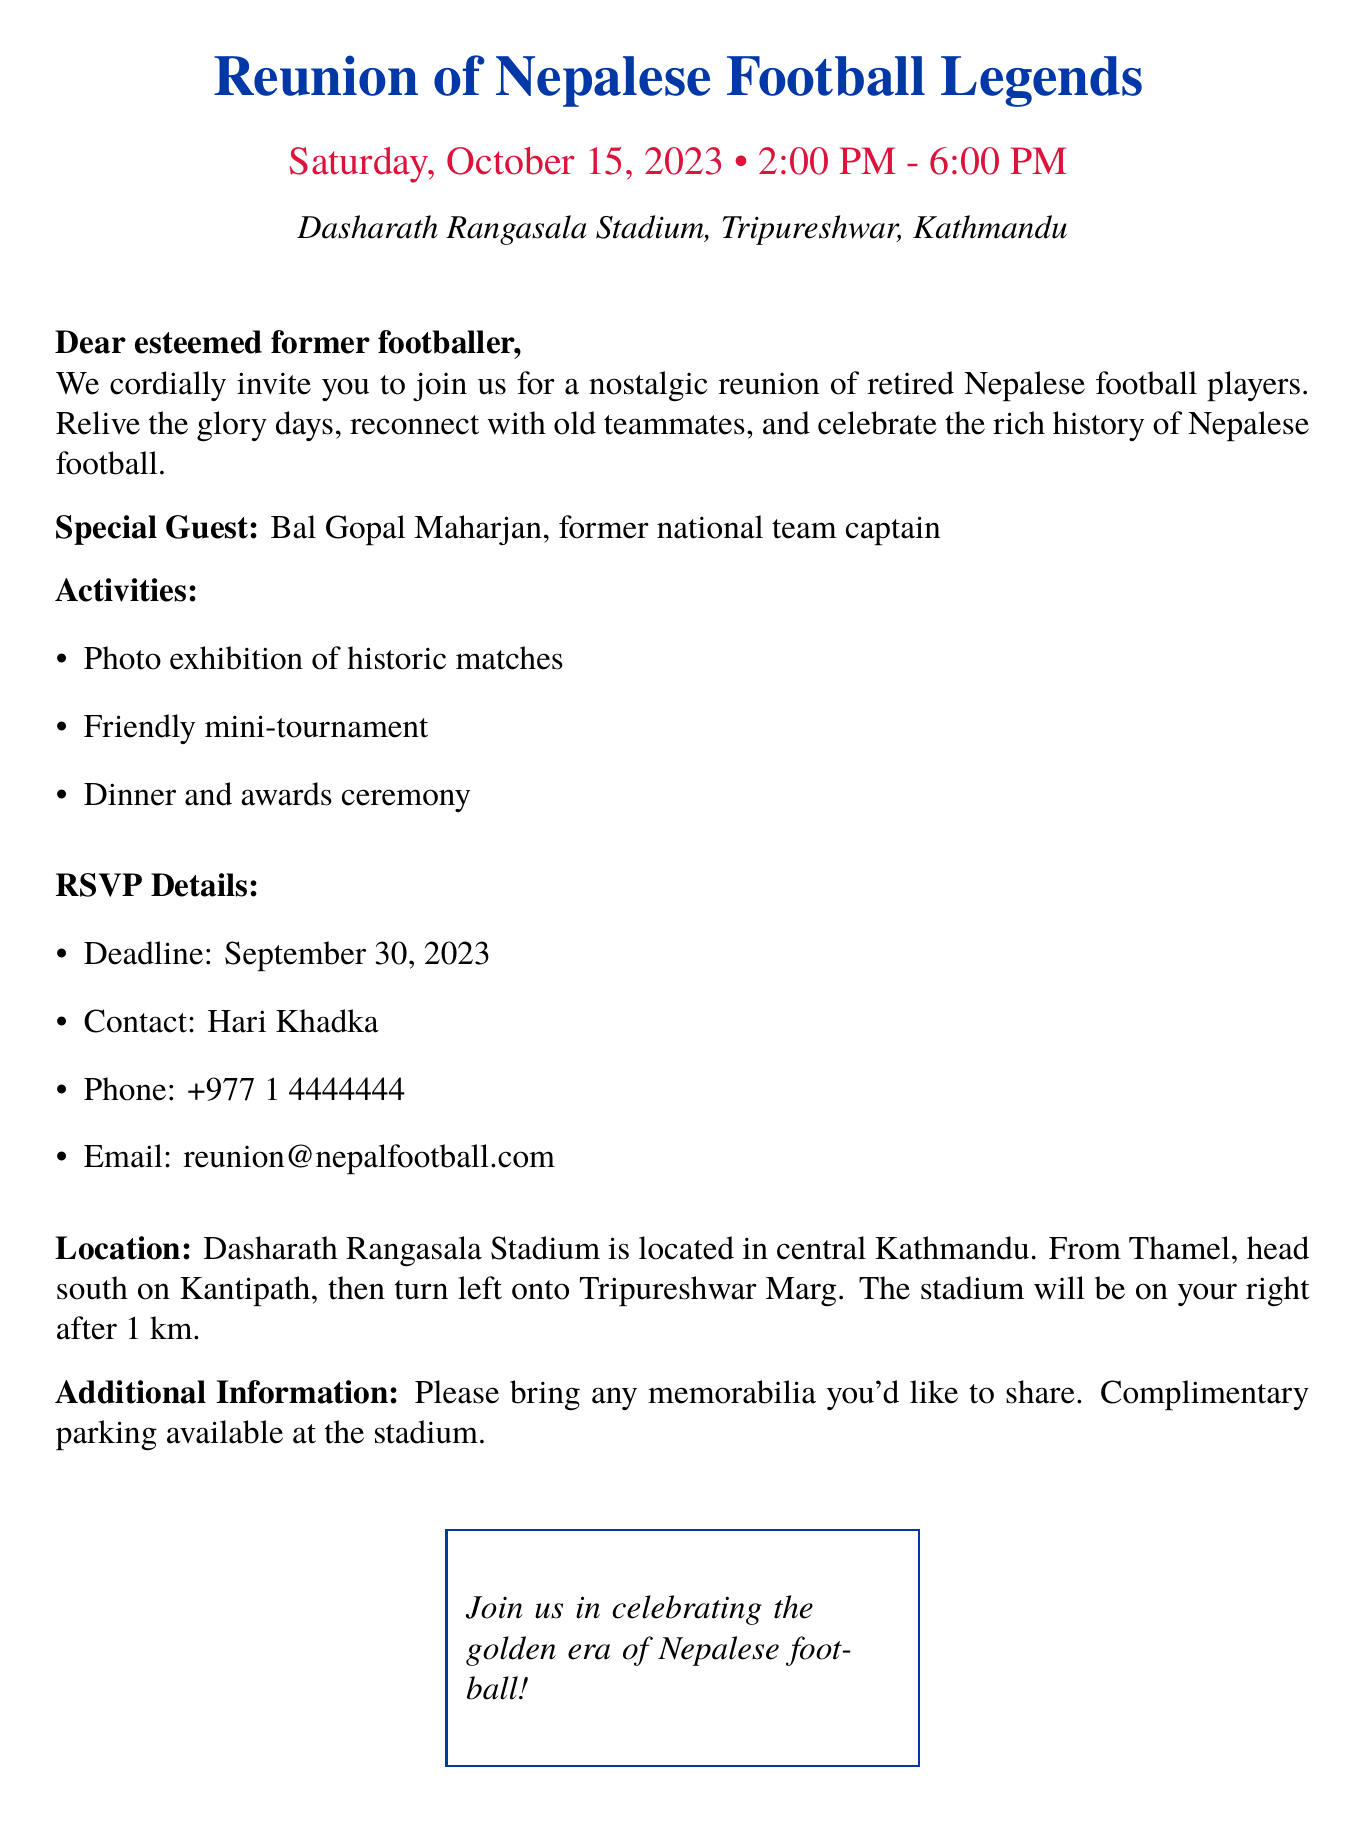What is the date of the reunion? The date of the reunion is explicitly stated in the document.
Answer: October 15, 2023 Who is the special guest at the event? The document mentions a special guest who is a former national team captain.
Answer: Bal Gopal Maharjan What is the RSVP deadline? The deadline for RSVPs is mentioned in the document.
Answer: September 30, 2023 What time does the reunion start? The starting time of the reunion is clearly provided in the document.
Answer: 2:00 PM What is the location of the event? The venue for the reunion is specified in the document.
Answer: Dasharath Rangasala Stadium What activities are planned for the reunion? The document lists activities that will take place during the reunion.
Answer: Photo exhibition, friendly mini-tournament, dinner and awards ceremony What is the contact number for RSVPs? The document provides a specific phone number for RSVPs.
Answer: +977 1 4444444 Is there parking available at the venue? The document mentions parking availability for attendees.
Answer: Complimentary parking 